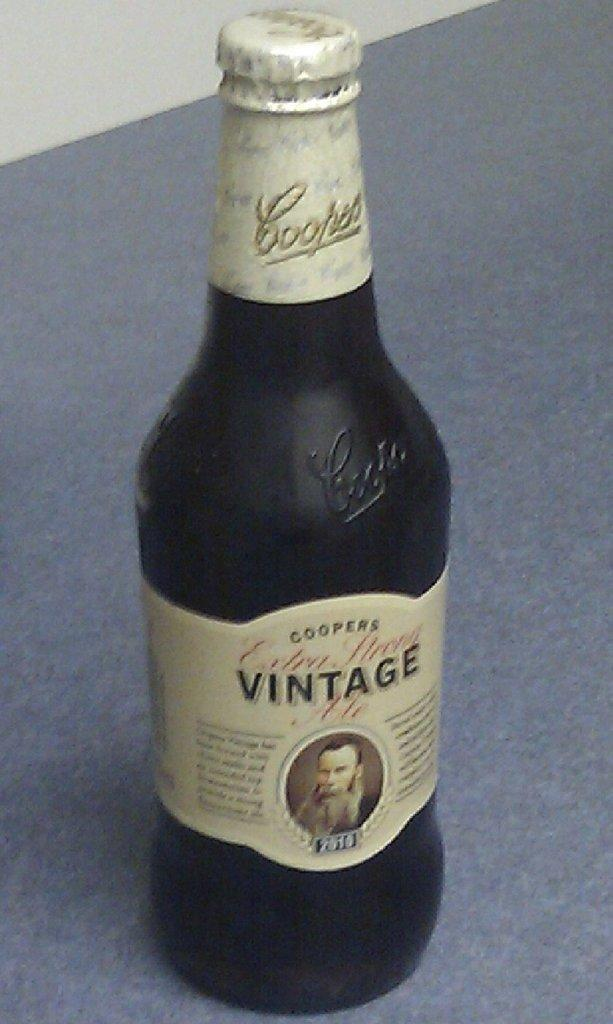<image>
Write a terse but informative summary of the picture. A bottle of Vintage beer has a man with a beard on the label. 